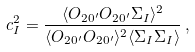Convert formula to latex. <formula><loc_0><loc_0><loc_500><loc_500>c _ { I } ^ { 2 } = \frac { \langle O _ { 2 0 ^ { \prime } } O _ { 2 0 ^ { \prime } } \Sigma _ { I } \rangle ^ { 2 } } { \langle O _ { 2 0 ^ { \prime } } O _ { 2 0 ^ { \prime } } \rangle ^ { 2 } \langle \Sigma _ { I } \Sigma _ { I } \rangle } \, ,</formula> 